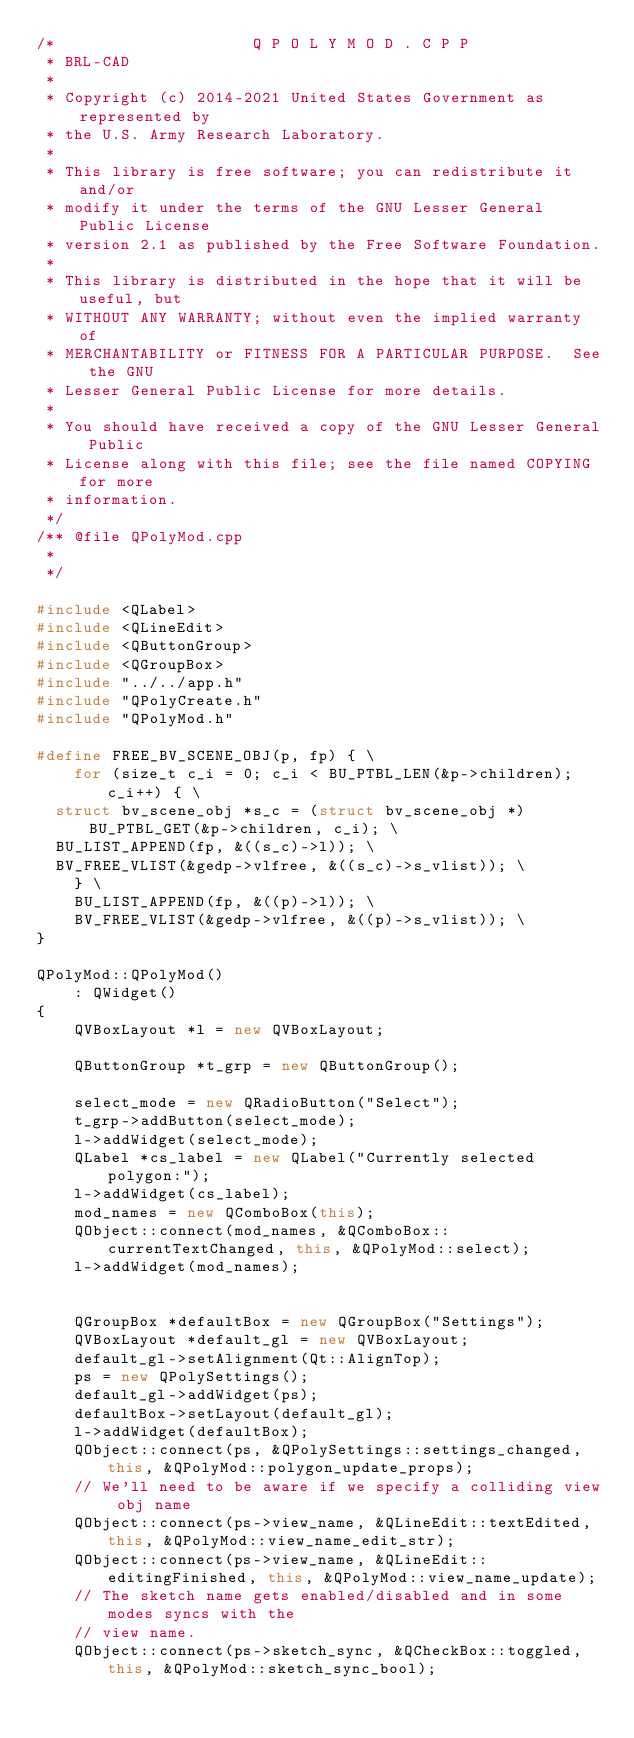<code> <loc_0><loc_0><loc_500><loc_500><_C++_>/*                     Q P O L Y M O D . C P P
 * BRL-CAD
 *
 * Copyright (c) 2014-2021 United States Government as represented by
 * the U.S. Army Research Laboratory.
 *
 * This library is free software; you can redistribute it and/or
 * modify it under the terms of the GNU Lesser General Public License
 * version 2.1 as published by the Free Software Foundation.
 *
 * This library is distributed in the hope that it will be useful, but
 * WITHOUT ANY WARRANTY; without even the implied warranty of
 * MERCHANTABILITY or FITNESS FOR A PARTICULAR PURPOSE.  See the GNU
 * Lesser General Public License for more details.
 *
 * You should have received a copy of the GNU Lesser General Public
 * License along with this file; see the file named COPYING for more
 * information.
 */
/** @file QPolyMod.cpp
 *
 */

#include <QLabel>
#include <QLineEdit>
#include <QButtonGroup>
#include <QGroupBox>
#include "../../app.h"
#include "QPolyCreate.h"
#include "QPolyMod.h"

#define FREE_BV_SCENE_OBJ(p, fp) { \
    for (size_t c_i = 0; c_i < BU_PTBL_LEN(&p->children); c_i++) { \
	struct bv_scene_obj *s_c = (struct bv_scene_obj *)BU_PTBL_GET(&p->children, c_i); \
	BU_LIST_APPEND(fp, &((s_c)->l)); \
	BV_FREE_VLIST(&gedp->vlfree, &((s_c)->s_vlist)); \
    } \
    BU_LIST_APPEND(fp, &((p)->l)); \
    BV_FREE_VLIST(&gedp->vlfree, &((p)->s_vlist)); \
}

QPolyMod::QPolyMod()
    : QWidget()
{
    QVBoxLayout *l = new QVBoxLayout;

    QButtonGroup *t_grp = new QButtonGroup();

    select_mode = new QRadioButton("Select");
    t_grp->addButton(select_mode);
    l->addWidget(select_mode);
    QLabel *cs_label = new QLabel("Currently selected polygon:");
    l->addWidget(cs_label);
    mod_names = new QComboBox(this);
    QObject::connect(mod_names, &QComboBox::currentTextChanged, this, &QPolyMod::select);
    l->addWidget(mod_names);


    QGroupBox *defaultBox = new QGroupBox("Settings");
    QVBoxLayout *default_gl = new QVBoxLayout;
    default_gl->setAlignment(Qt::AlignTop);
    ps = new QPolySettings();
    default_gl->addWidget(ps);
    defaultBox->setLayout(default_gl);
    l->addWidget(defaultBox);
    QObject::connect(ps, &QPolySettings::settings_changed, this, &QPolyMod::polygon_update_props);
    // We'll need to be aware if we specify a colliding view obj name
    QObject::connect(ps->view_name, &QLineEdit::textEdited, this, &QPolyMod::view_name_edit_str);
    QObject::connect(ps->view_name, &QLineEdit::editingFinished, this, &QPolyMod::view_name_update);
    // The sketch name gets enabled/disabled and in some modes syncs with the
    // view name.
    QObject::connect(ps->sketch_sync, &QCheckBox::toggled, this, &QPolyMod::sketch_sync_bool);</code> 